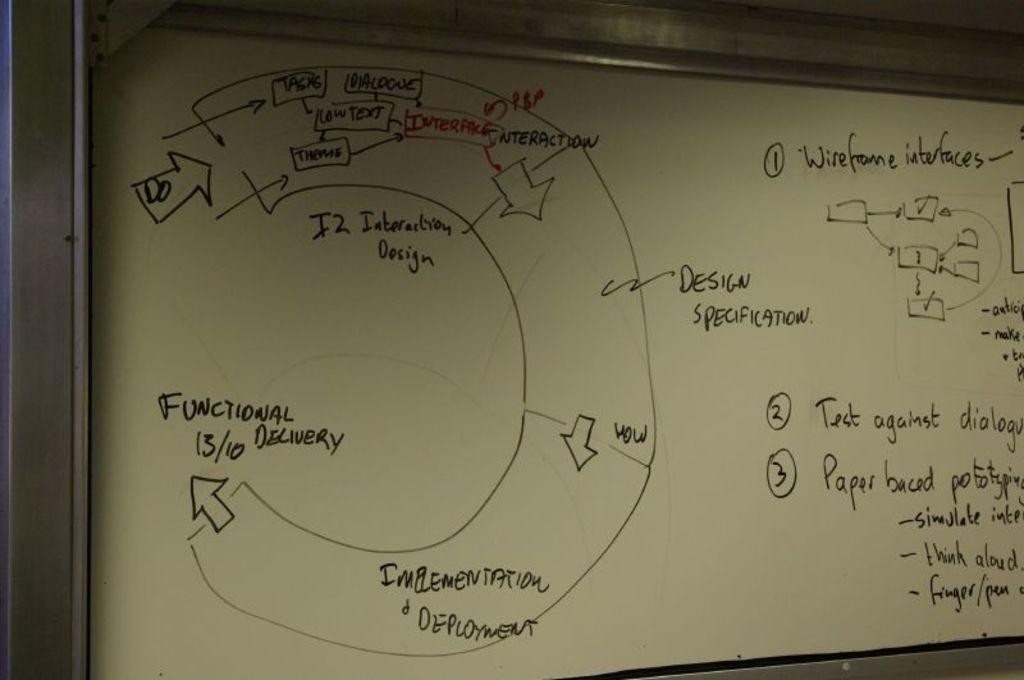<image>
Create a compact narrative representing the image presented. The whiteboard has a flowcart with functional delivery as the endpoint. 